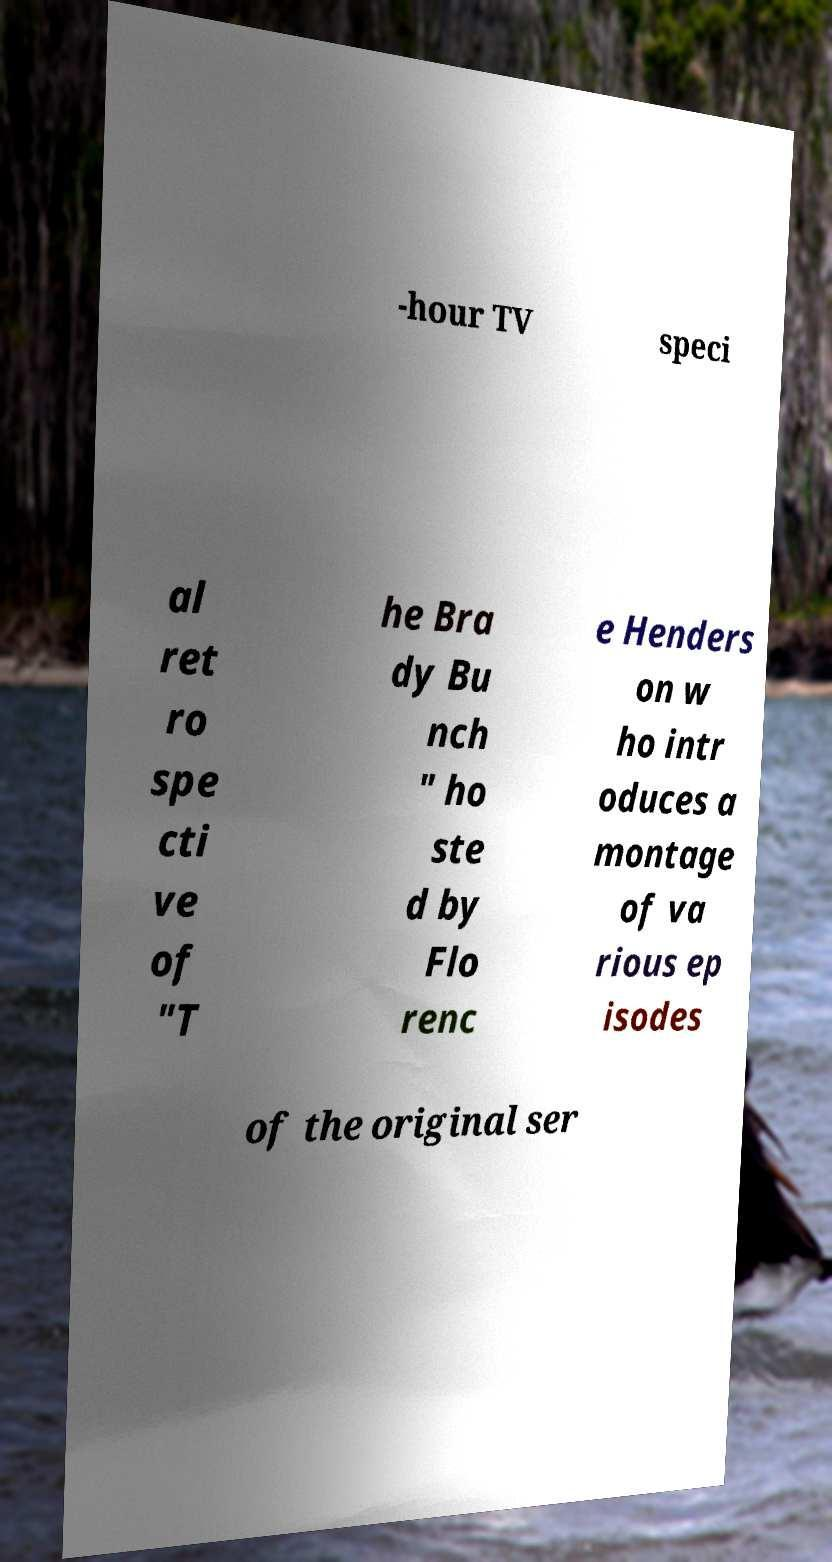Please read and relay the text visible in this image. What does it say? -hour TV speci al ret ro spe cti ve of "T he Bra dy Bu nch " ho ste d by Flo renc e Henders on w ho intr oduces a montage of va rious ep isodes of the original ser 